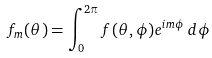<formula> <loc_0><loc_0><loc_500><loc_500>f _ { m } ( \theta ) = \int _ { 0 } ^ { 2 \pi } f ( \theta , \phi ) e ^ { i m \phi } \, d \phi</formula> 